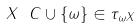Convert formula to latex. <formula><loc_0><loc_0><loc_500><loc_500>X \ C \cup \{ \omega \} \in \tau _ { \omega X }</formula> 